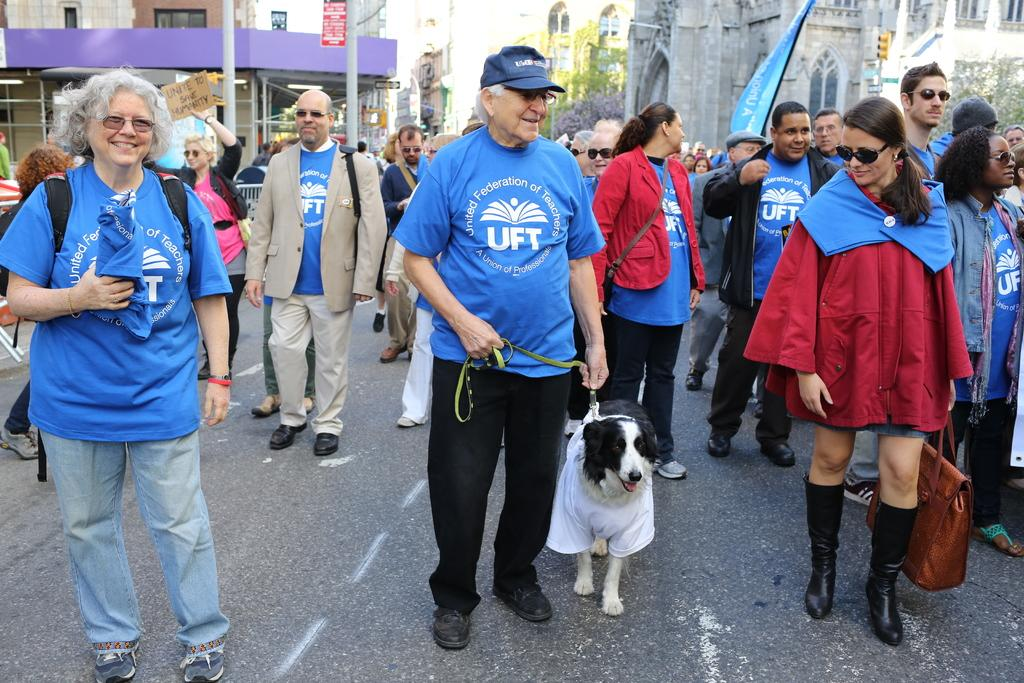How many people are in the image? There is a group of people in the image. What are the people doing in the image? The people are standing in the road. What are the people wearing in the image? The people are wearing blue shirts. What other living creature is present in the road? There is a dog in the road. What can be seen in the background of the image? There is a flag, a building, a tree, a pole, and a name board in the background of the image. Is there a bear visible in the image during the rainstorm? There is no bear or rainstorm present in the image. What is the chance of winning a prize while standing in the road with the group of people? The image does not provide any information about winning a prize or the likelihood of doing so. 